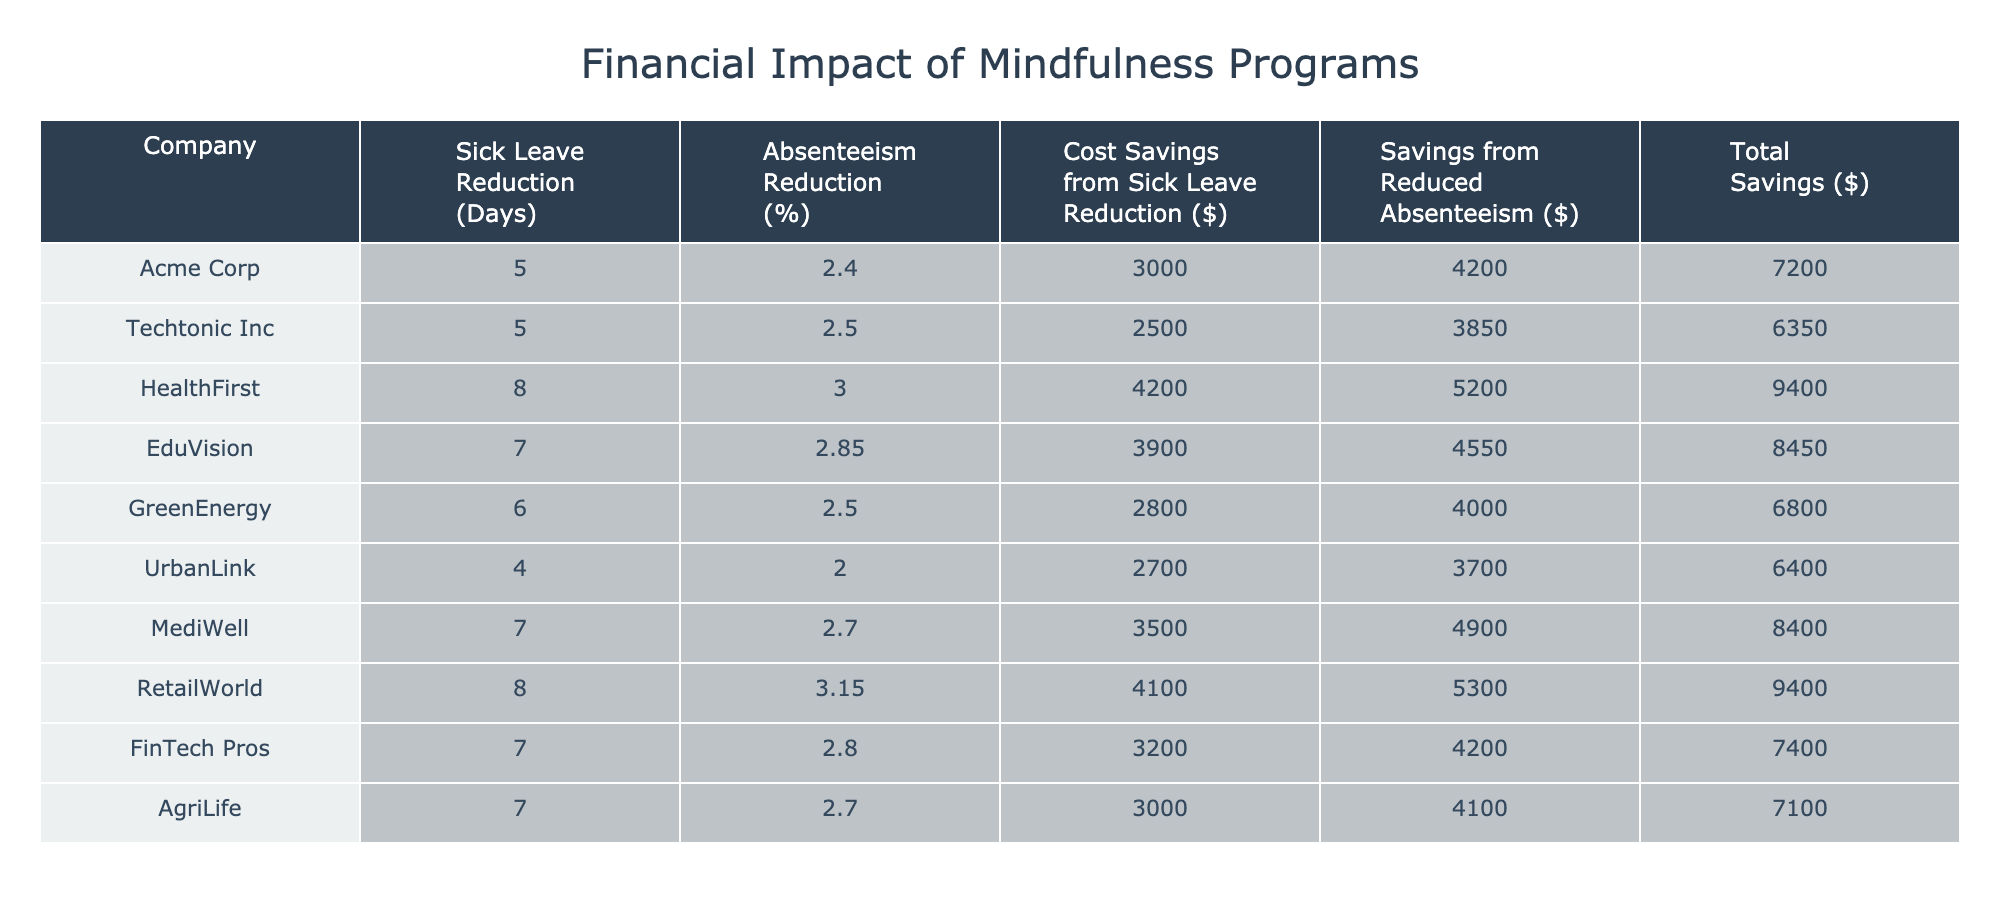What is the sick leave reduction for HealthFirst? The table shows that the sick leave days for HealthFirst reduced from 20 to 12. Thus, the sick leave reduction is calculated as 20 - 12 = 8 days.
Answer: 8 days Which company achieved the highest savings from reduced absenteeism? By reviewing the "Savings from Reduced Absenteeism" column, we find that RetailWorld has the highest value at 5300 dollars.
Answer: RetailWorld What is the average cost of sick leave reduction across all companies? The total cost of sick leave reduction is calculated by summing the individual costs: 3000 + 2500 + 4200 + 3900 + 2800 + 2700 + 3500 + 4100 + 3200 + 3000 = 30500 dollars. With 10 companies, the average is 30500 / 10 = 3050 dollars.
Answer: 3050 dollars Did any company show an increase in absenteeism rate after the mindfulness program? Evaluating the "Pre-Mindfulness Absenteeism Rate" and "Post-Mindfulness Absenteeism Rate," we see no company has a post-rate higher than the pre-rate. Thus, the answer is no.
Answer: No Which company had the lowest absenteeism reduction percentage? Looking at the "Absenteeism Reduction (%)" column, UrbanLink has the lowest value at 2.00%, calculated as (5.80% - 3.80%) = 2.00%.
Answer: UrbanLink What is the total savings for AgriLife? The total savings for AgriLife is found by adding the cost of sick leave reduction and savings from reduced absenteeism: 3000 + 4100 = 7100 dollars.
Answer: 7100 dollars Among the companies, how many had a sick leave reduction greater than 5 days? By checking the "Sick Leave Reduction (Days)" column, the companies with reductions greater than 5 days are Acme Corp (5), HealthFirst (8), EduVision (7), GreenEnergy (6), MediWell (7), RetailWorld (8), and AgriLife (7), totaling 7 companies.
Answer: 7 companies What is the correlation between sick leave reduction and total savings, based on the data? To determine the correlation, we need to observe the increase in total savings as sick leave days decrease. Most companies with a higher sick leave reduction tend to have significant total savings, indicating a positive correlation. However, a precise correlation coefficient would require calculations beyond the table.
Answer: Positive correlation Which company had the most significant reduction in sick leave days and total savings combined? Analyzing the "Sick Leave Reduction (Days)" along with the "Total Savings ($)," HealthFirst had a sick leave reduction of 8 days and total savings of 9400 dollars (4200 + 5200), giving it a combined score of 8 days and a $9400 savings. This is the highest combined score.
Answer: HealthFirst 